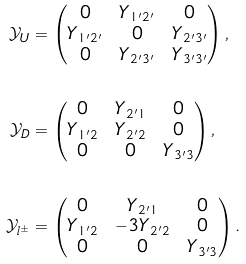<formula> <loc_0><loc_0><loc_500><loc_500>\mathcal { Y } _ { U } & = \begin{pmatrix} 0 & Y _ { 1 ^ { \prime } 2 ^ { \prime } } & 0 \\ Y _ { 1 ^ { \prime } 2 ^ { \prime } } & 0 & Y _ { 2 ^ { \prime } 3 ^ { \prime } } \\ 0 & Y _ { 2 ^ { \prime } 3 ^ { \prime } } & Y _ { 3 ^ { \prime } 3 ^ { \prime } } \end{pmatrix} , \\ \\ \mathcal { Y } _ { D } & = \begin{pmatrix} 0 & Y _ { 2 ^ { \prime } 1 } & 0 \\ Y _ { 1 ^ { \prime } 2 } & Y _ { 2 ^ { \prime } 2 } & 0 \\ 0 & 0 & Y _ { 3 ^ { \prime } 3 } \end{pmatrix} , \\ \\ \mathcal { Y } _ { l ^ { \pm } } & = \begin{pmatrix} 0 & Y _ { 2 ^ { \prime } 1 } & 0 \\ Y _ { 1 ^ { \prime } 2 } & - 3 Y _ { 2 ^ { \prime } 2 } & 0 \\ 0 & 0 & Y _ { 3 ^ { \prime } 3 } \end{pmatrix} .</formula> 